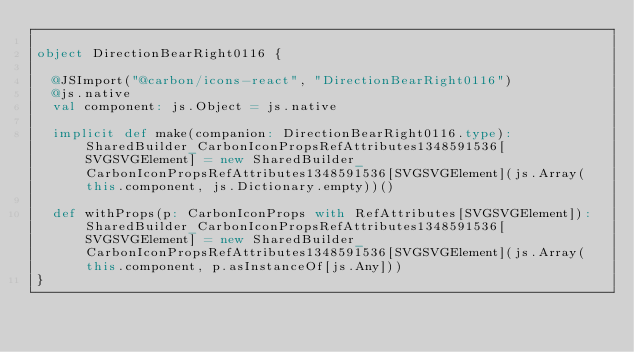Convert code to text. <code><loc_0><loc_0><loc_500><loc_500><_Scala_>
object DirectionBearRight0116 {
  
  @JSImport("@carbon/icons-react", "DirectionBearRight0116")
  @js.native
  val component: js.Object = js.native
  
  implicit def make(companion: DirectionBearRight0116.type): SharedBuilder_CarbonIconPropsRefAttributes1348591536[SVGSVGElement] = new SharedBuilder_CarbonIconPropsRefAttributes1348591536[SVGSVGElement](js.Array(this.component, js.Dictionary.empty))()
  
  def withProps(p: CarbonIconProps with RefAttributes[SVGSVGElement]): SharedBuilder_CarbonIconPropsRefAttributes1348591536[SVGSVGElement] = new SharedBuilder_CarbonIconPropsRefAttributes1348591536[SVGSVGElement](js.Array(this.component, p.asInstanceOf[js.Any]))
}
</code> 